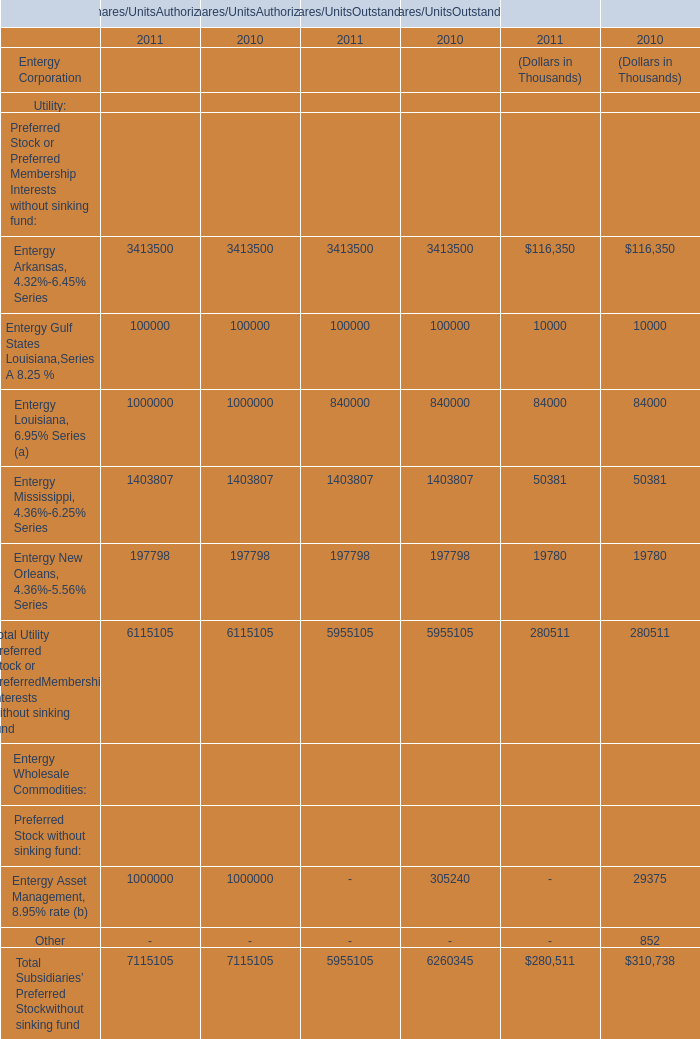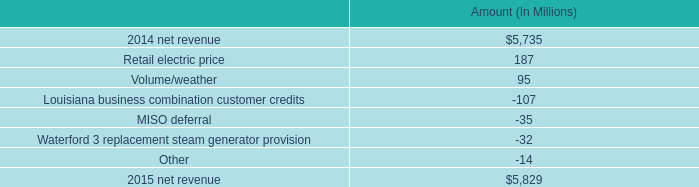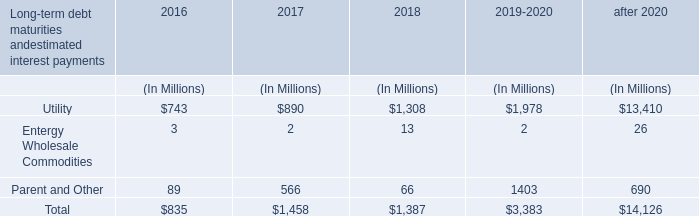What's the current growth rate of Entergy Gulf States Louisiana,Series A 8.25 %? 
Computations: ((((100000 + 100000) + 100000) - ((100000 + 100000) + 100000)) / ((100000 + 100000) + 100000))
Answer: 0.0. 